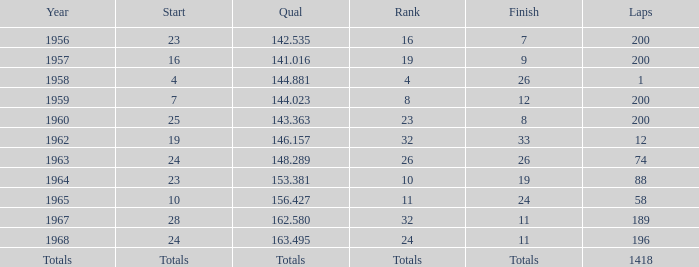Which qual has both 200 total laps and took place in 1957? 141.016. 